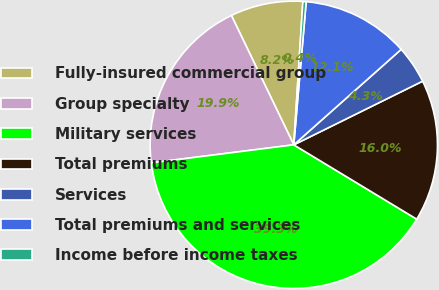Convert chart to OTSL. <chart><loc_0><loc_0><loc_500><loc_500><pie_chart><fcel>Fully-insured commercial group<fcel>Group specialty<fcel>Military services<fcel>Total premiums<fcel>Services<fcel>Total premiums and services<fcel>Income before income taxes<nl><fcel>8.16%<fcel>19.85%<fcel>39.34%<fcel>15.96%<fcel>4.26%<fcel>12.06%<fcel>0.37%<nl></chart> 